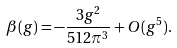<formula> <loc_0><loc_0><loc_500><loc_500>\beta ( g ) = - \frac { 3 g ^ { 2 } } { 5 1 2 \pi ^ { 3 } } + O ( g ^ { 5 } ) .</formula> 